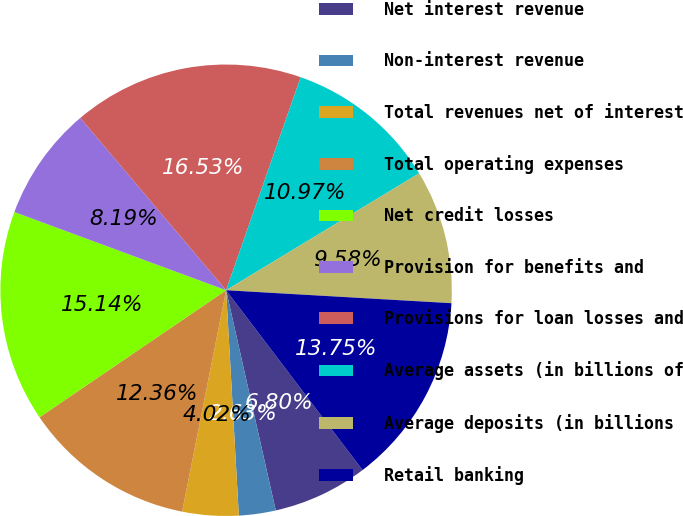<chart> <loc_0><loc_0><loc_500><loc_500><pie_chart><fcel>Net interest revenue<fcel>Non-interest revenue<fcel>Total revenues net of interest<fcel>Total operating expenses<fcel>Net credit losses<fcel>Provision for benefits and<fcel>Provisions for loan losses and<fcel>Average assets (in billions of<fcel>Average deposits (in billions<fcel>Retail banking<nl><fcel>6.8%<fcel>2.63%<fcel>4.02%<fcel>12.36%<fcel>15.14%<fcel>8.19%<fcel>16.53%<fcel>10.97%<fcel>9.58%<fcel>13.75%<nl></chart> 